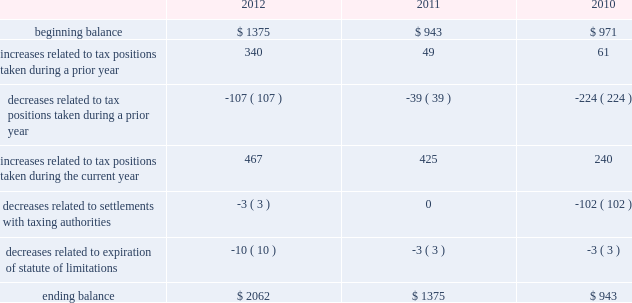The aggregate changes in the balance of gross unrecognized tax benefits , which excludes interest and penalties , for 2012 , 2011 , and 2010 , is as follows ( in millions ) : .
The company includes interest and penalties related to unrecognized tax benefits within the provision for income taxes .
As of september 29 , 2012 and september 24 , 2011 , the total amount of gross interest and penalties accrued was $ 401 million and $ 261 million , respectively , which is classified as non-current liabilities in the consolidated balance sheets .
In connection with tax matters , the company recognized interest expense in 2012 and 2011 of $ 140 million and $ 14 million , respectively , and in 2010 the company recognized an interest benefit of $ 43 million .
The company is subject to taxation and files income tax returns in the u.s .
Federal jurisdiction and in many state and foreign jurisdictions .
For u.s .
Federal income tax purposes , all years prior to 2004 are closed .
The internal revenue service ( the 201cirs 201d ) has completed its field audit of the company 2019s federal income tax returns for the years 2004 through 2006 and proposed certain adjustments .
The company has contested certain of these adjustments through the irs appeals office .
The irs is currently examining the years 2007 through 2009 .
In addition , the company is also subject to audits by state , local and foreign tax authorities .
In major states and major foreign jurisdictions , the years subsequent to 1989 and 2002 , respectively , generally remain open and could be subject to examination by the taxing authorities .
Management believes that an adequate provision has been made for any adjustments that may result from tax examinations .
However , the outcome of tax audits cannot be predicted with certainty .
If any issues addressed in the company 2019s tax audits are resolved in a manner not consistent with management 2019s expectations , the company could be required to adjust its provision for income tax in the period such resolution occurs .
Although timing of the resolution and/or closure of audits is not certain , the company believes it is reasonably possible that tax audit resolutions could reduce its unrecognized tax benefits by between $ 120 million and $ 170 million in the next 12 months .
Note 6 2013 shareholders 2019 equity and share-based compensation preferred stock the company has five million shares of authorized preferred stock , none of which is issued or outstanding .
Under the terms of the company 2019s restated articles of incorporation , the board of directors is authorized to determine or alter the rights , preferences , privileges and restrictions of the company 2019s authorized but unissued shares of preferred stock .
Dividend and stock repurchase program in 2012 , the board of directors of the company approved a dividend policy pursuant to which it plans to make , subject to subsequent declaration , quarterly dividends of $ 2.65 per share .
On july 24 , 2012 , the board of directors declared a dividend of $ 2.65 per share to shareholders of record as of the close of business on august 13 , 2012 .
The company paid $ 2.5 billion in conjunction with this dividend on august 16 , 2012 .
No dividends were declared in the first three quarters of 2012 or in 2011 and 2010. .
What was the percentage change in the gross unrecognized tax benefits between 2011 and 2012? 
Computations: ((2062 - 1375) / 1375)
Answer: 0.49964. 